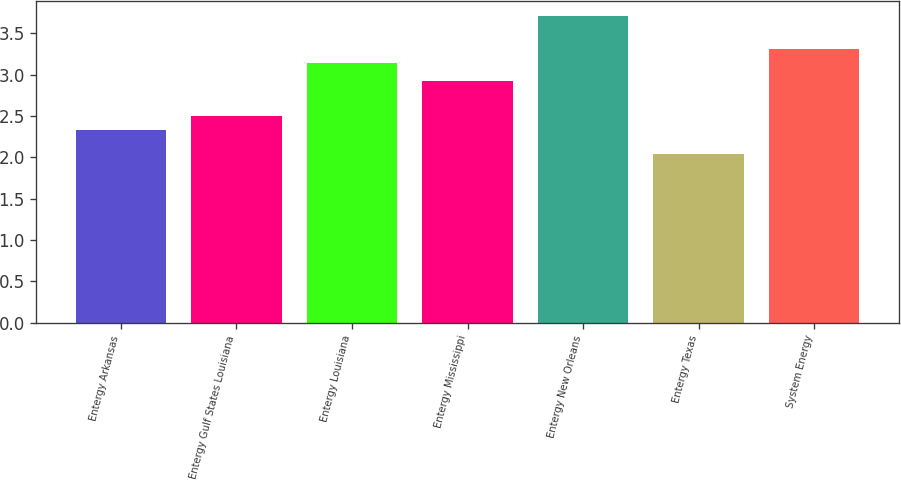Convert chart to OTSL. <chart><loc_0><loc_0><loc_500><loc_500><bar_chart><fcel>Entergy Arkansas<fcel>Entergy Gulf States Louisiana<fcel>Entergy Louisiana<fcel>Entergy Mississippi<fcel>Entergy New Orleans<fcel>Entergy Texas<fcel>System Energy<nl><fcel>2.33<fcel>2.5<fcel>3.14<fcel>2.92<fcel>3.71<fcel>2.04<fcel>3.31<nl></chart> 